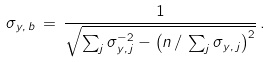Convert formula to latex. <formula><loc_0><loc_0><loc_500><loc_500>\sigma _ { y , \, b } \, = \, \frac { 1 } { \sqrt { \sum _ { j } \sigma _ { y , \, j } ^ { - 2 } - \left ( n \, / \, \sum _ { j } \sigma _ { y , \, j } \right ) ^ { 2 } } } \, .</formula> 